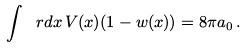Convert formula to latex. <formula><loc_0><loc_0><loc_500><loc_500>\int \ r d x \, V ( x ) ( 1 - w ( x ) ) = 8 \pi a _ { 0 } \, .</formula> 